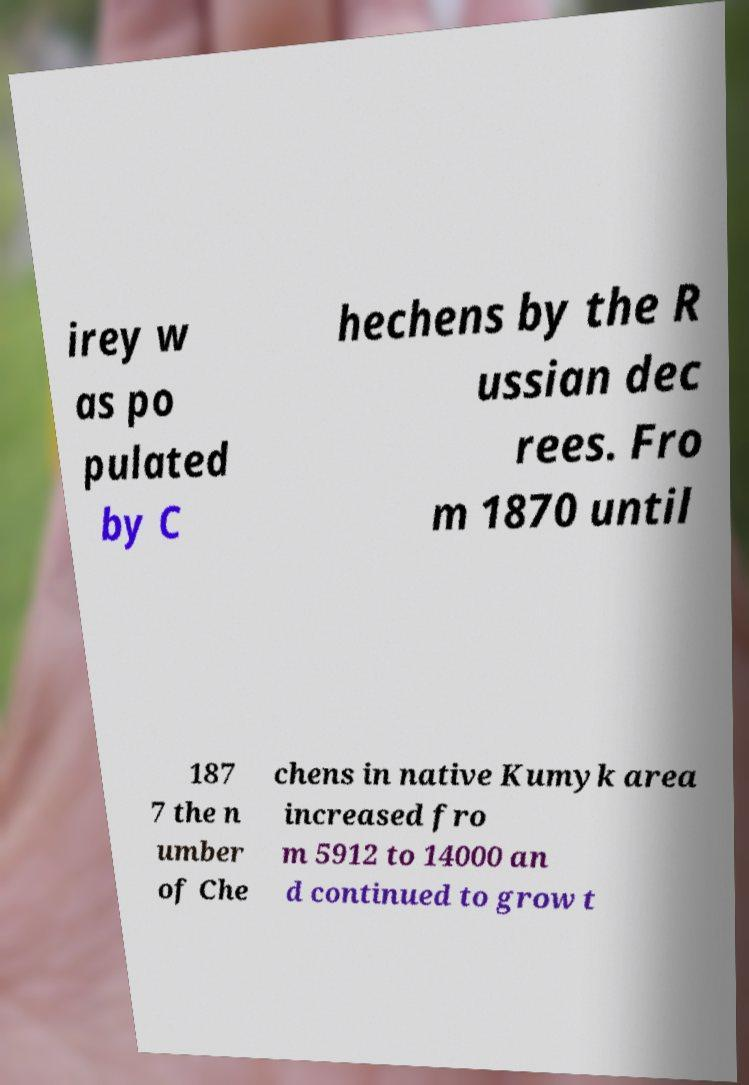For documentation purposes, I need the text within this image transcribed. Could you provide that? irey w as po pulated by C hechens by the R ussian dec rees. Fro m 1870 until 187 7 the n umber of Che chens in native Kumyk area increased fro m 5912 to 14000 an d continued to grow t 